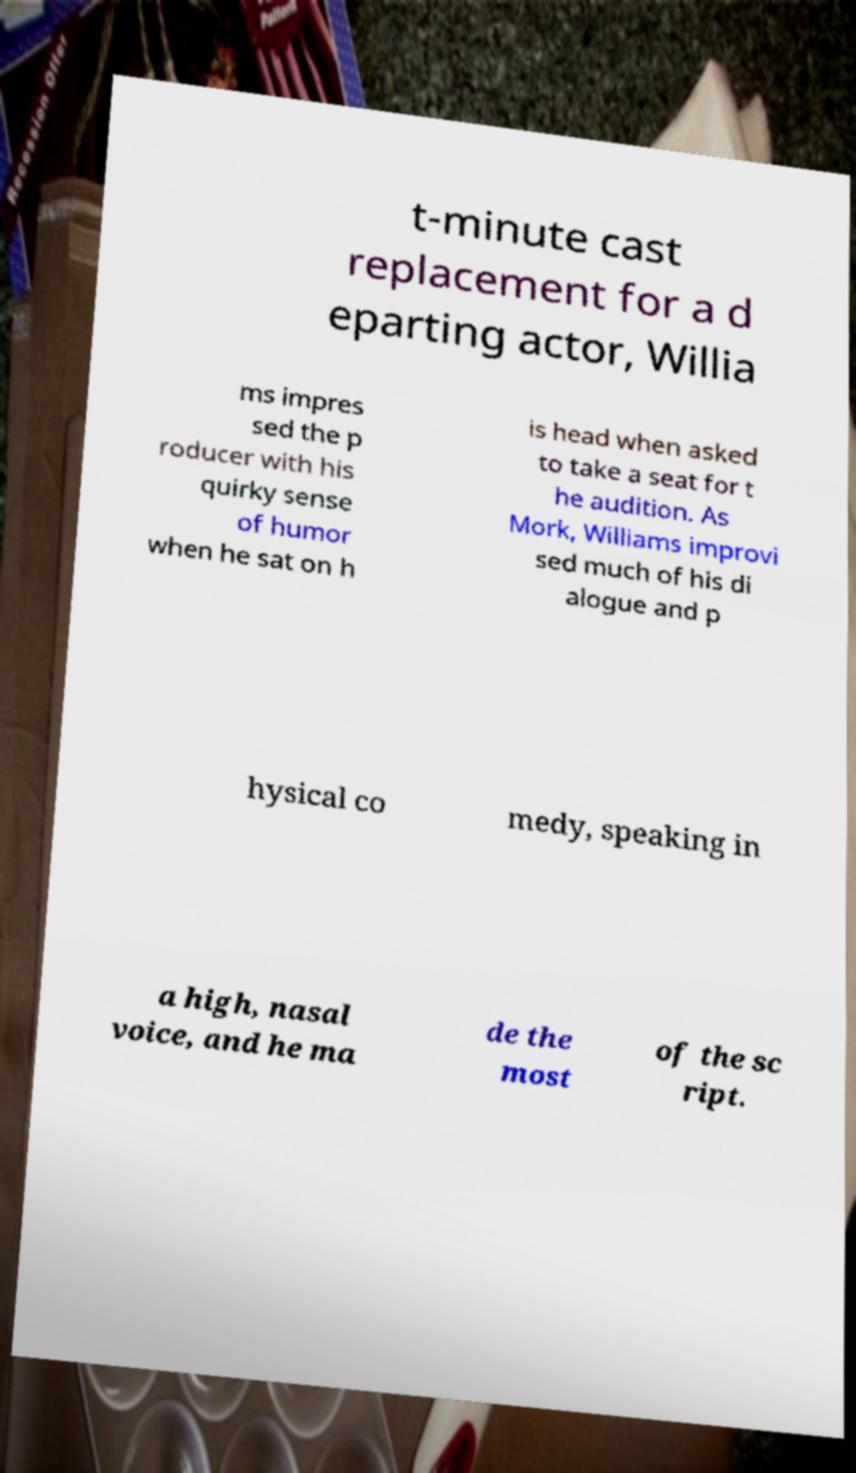I need the written content from this picture converted into text. Can you do that? t-minute cast replacement for a d eparting actor, Willia ms impres sed the p roducer with his quirky sense of humor when he sat on h is head when asked to take a seat for t he audition. As Mork, Williams improvi sed much of his di alogue and p hysical co medy, speaking in a high, nasal voice, and he ma de the most of the sc ript. 